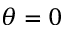Convert formula to latex. <formula><loc_0><loc_0><loc_500><loc_500>\theta = 0</formula> 